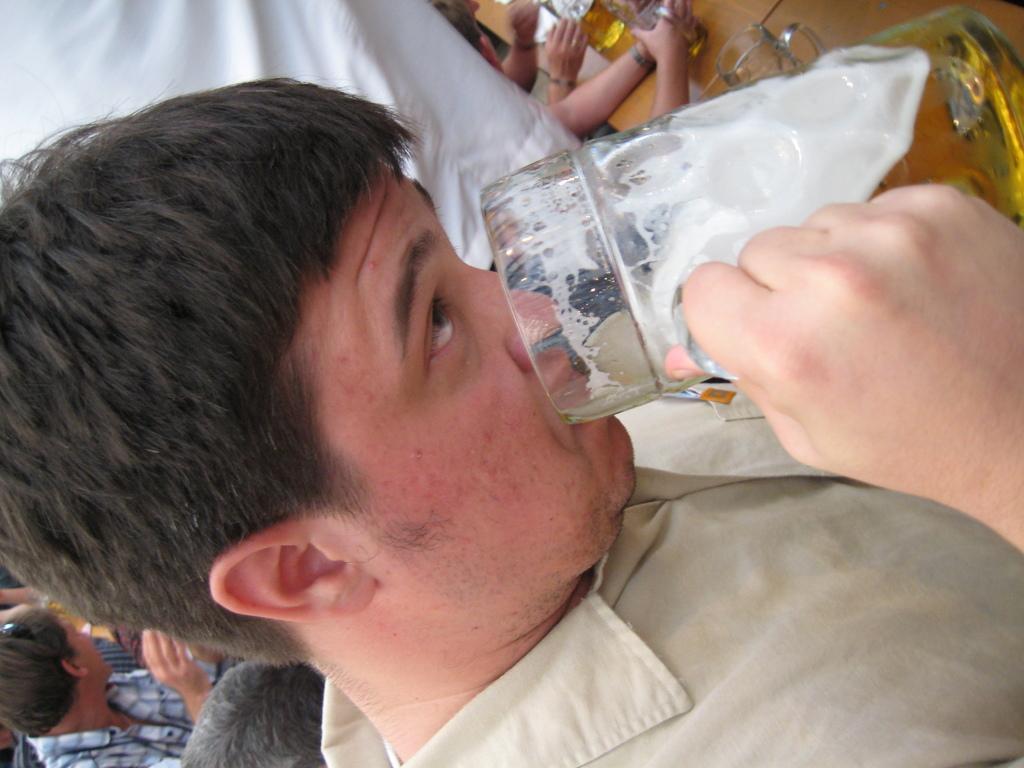Can you describe this image briefly? This picture shows few people seated and we see a man standing and holding a glass and drinking beer and we see few beer glasses on the table and we see few people seated on the back. 